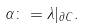<formula> <loc_0><loc_0><loc_500><loc_500>\alpha \colon = \lambda | _ { \partial C } .</formula> 